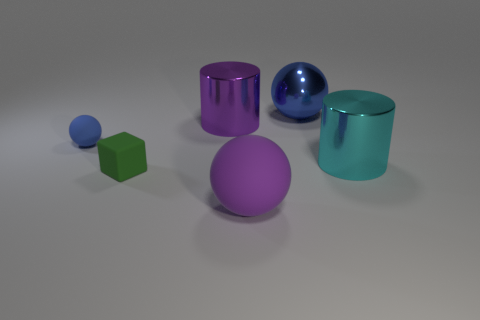The big purple thing that is behind the big metal cylinder that is on the right side of the big purple shiny thing is what shape?
Your response must be concise. Cylinder. What is the size of the thing that is the same color as the small sphere?
Give a very brief answer. Large. Does the tiny rubber thing that is to the left of the tiny green rubber block have the same shape as the big purple metallic thing?
Provide a succinct answer. No. Is the number of small blue rubber things that are in front of the rubber block greater than the number of tiny blocks that are right of the big purple cylinder?
Your response must be concise. No. There is a matte thing that is to the left of the green thing; what number of large purple objects are behind it?
Make the answer very short. 1. There is a large thing that is the same color as the big matte sphere; what material is it?
Offer a terse response. Metal. What number of other things are the same color as the metal sphere?
Give a very brief answer. 1. What color is the cylinder in front of the cylinder that is left of the big blue thing?
Offer a very short reply. Cyan. Are there any matte balls that have the same color as the rubber cube?
Keep it short and to the point. No. How many shiny objects are either big purple objects or green cubes?
Make the answer very short. 1. 